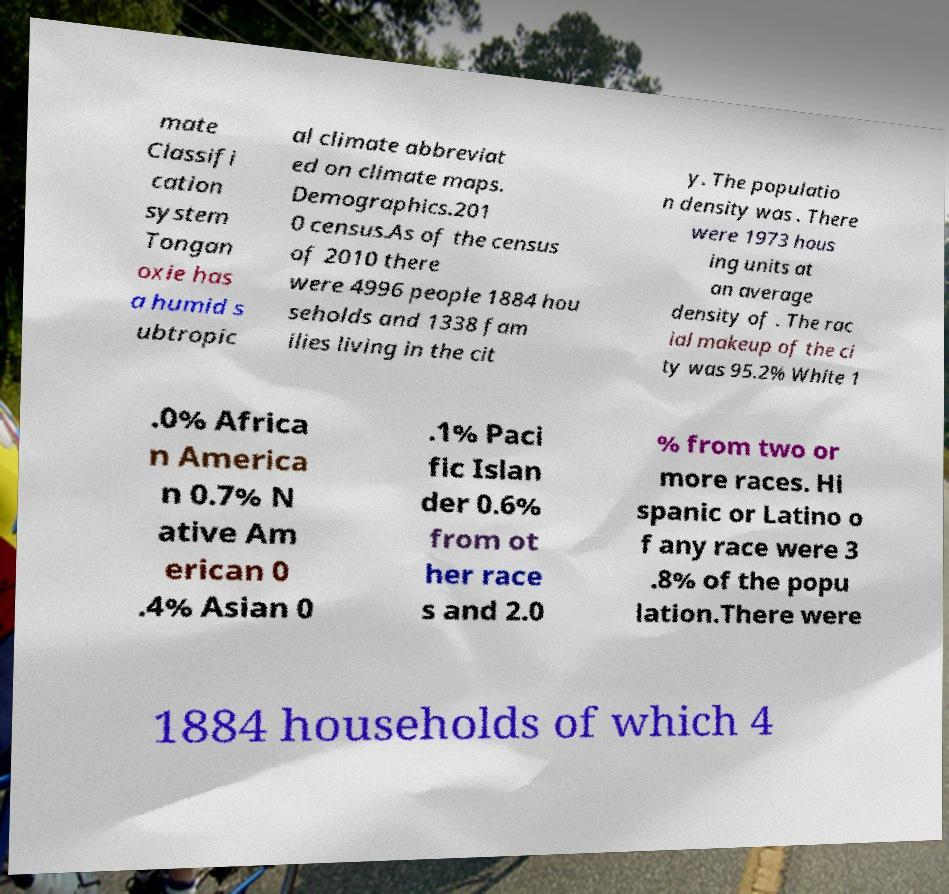For documentation purposes, I need the text within this image transcribed. Could you provide that? mate Classifi cation system Tongan oxie has a humid s ubtropic al climate abbreviat ed on climate maps. Demographics.201 0 census.As of the census of 2010 there were 4996 people 1884 hou seholds and 1338 fam ilies living in the cit y. The populatio n density was . There were 1973 hous ing units at an average density of . The rac ial makeup of the ci ty was 95.2% White 1 .0% Africa n America n 0.7% N ative Am erican 0 .4% Asian 0 .1% Paci fic Islan der 0.6% from ot her race s and 2.0 % from two or more races. Hi spanic or Latino o f any race were 3 .8% of the popu lation.There were 1884 households of which 4 